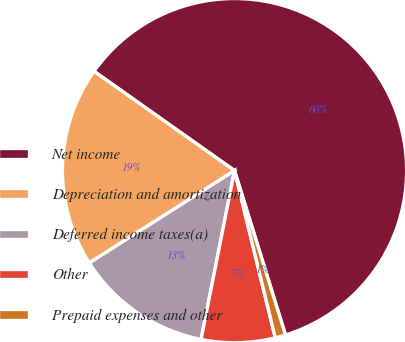Convert chart to OTSL. <chart><loc_0><loc_0><loc_500><loc_500><pie_chart><fcel>Net income<fcel>Depreciation and amortization<fcel>Deferred income taxes(a)<fcel>Other<fcel>Prepaid expenses and other<nl><fcel>60.42%<fcel>18.81%<fcel>12.87%<fcel>6.92%<fcel>0.98%<nl></chart> 